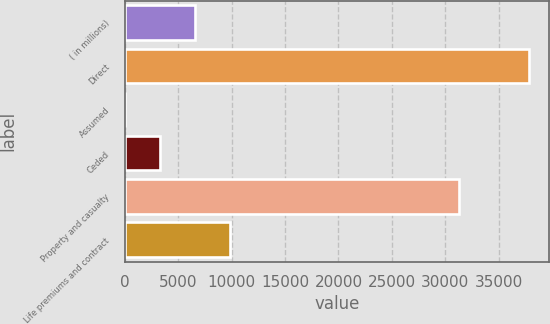<chart> <loc_0><loc_0><loc_500><loc_500><bar_chart><fcel>( in millions)<fcel>Direct<fcel>Assumed<fcel>Ceded<fcel>Property and casualty<fcel>Life premiums and contract<nl><fcel>6560.4<fcel>37820.4<fcel>47<fcel>3303.7<fcel>31307<fcel>9817.1<nl></chart> 